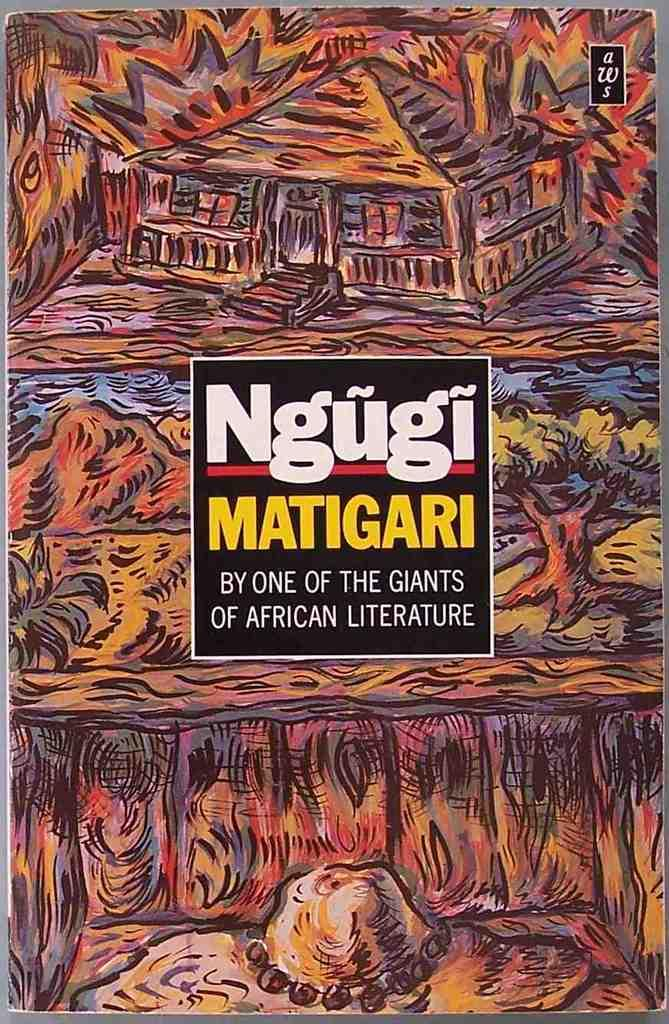<image>
Describe the image concisely. A book titled Ngugi Matigari subtitled "By one of the Giants of African Literature". 